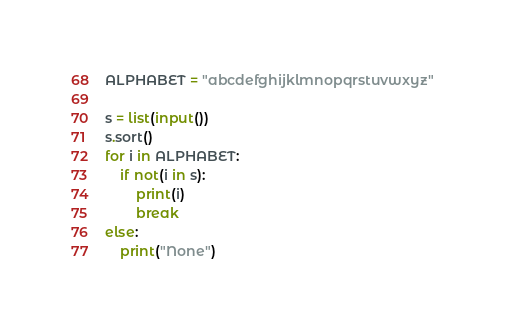Convert code to text. <code><loc_0><loc_0><loc_500><loc_500><_Python_>ALPHABET = "abcdefghijklmnopqrstuvwxyz"

s = list(input())
s.sort()
for i in ALPHABET:
    if not(i in s):
        print(i)
        break
else:
    print("None")
</code> 